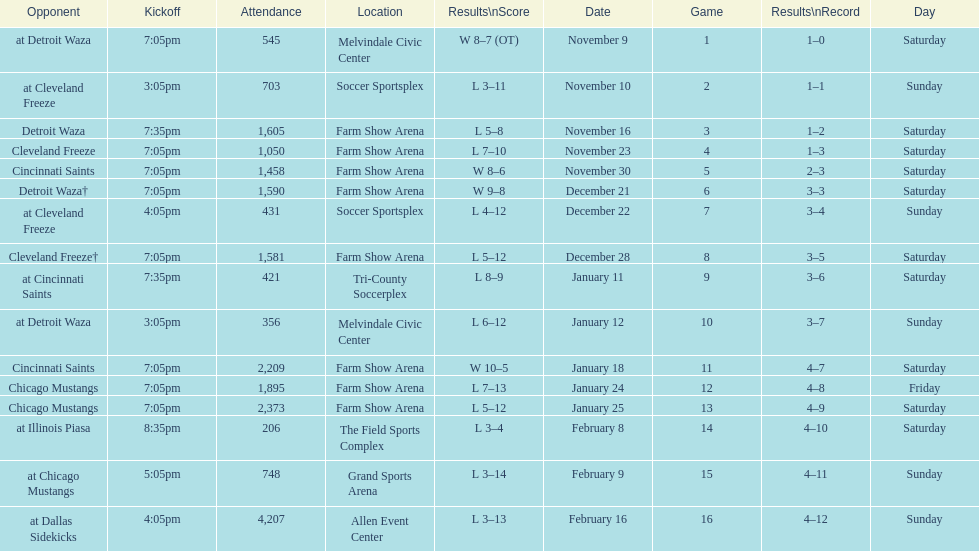Which opponent is listed after cleveland freeze in the table? Detroit Waza. Can you give me this table as a dict? {'header': ['Opponent', 'Kickoff', 'Attendance', 'Location', 'Results\\nScore', 'Date', 'Game', 'Results\\nRecord', 'Day'], 'rows': [['at Detroit Waza', '7:05pm', '545', 'Melvindale Civic Center', 'W 8–7 (OT)', 'November 9', '1', '1–0', 'Saturday'], ['at Cleveland Freeze', '3:05pm', '703', 'Soccer Sportsplex', 'L 3–11', 'November 10', '2', '1–1', 'Sunday'], ['Detroit Waza', '7:35pm', '1,605', 'Farm Show Arena', 'L 5–8', 'November 16', '3', '1–2', 'Saturday'], ['Cleveland Freeze', '7:05pm', '1,050', 'Farm Show Arena', 'L 7–10', 'November 23', '4', '1–3', 'Saturday'], ['Cincinnati Saints', '7:05pm', '1,458', 'Farm Show Arena', 'W 8–6', 'November 30', '5', '2–3', 'Saturday'], ['Detroit Waza†', '7:05pm', '1,590', 'Farm Show Arena', 'W 9–8', 'December 21', '6', '3–3', 'Saturday'], ['at Cleveland Freeze', '4:05pm', '431', 'Soccer Sportsplex', 'L 4–12', 'December 22', '7', '3–4', 'Sunday'], ['Cleveland Freeze†', '7:05pm', '1,581', 'Farm Show Arena', 'L 5–12', 'December 28', '8', '3–5', 'Saturday'], ['at Cincinnati Saints', '7:35pm', '421', 'Tri-County Soccerplex', 'L 8–9', 'January 11', '9', '3–6', 'Saturday'], ['at Detroit Waza', '3:05pm', '356', 'Melvindale Civic Center', 'L 6–12', 'January 12', '10', '3–7', 'Sunday'], ['Cincinnati Saints', '7:05pm', '2,209', 'Farm Show Arena', 'W 10–5', 'January 18', '11', '4–7', 'Saturday'], ['Chicago Mustangs', '7:05pm', '1,895', 'Farm Show Arena', 'L 7–13', 'January 24', '12', '4–8', 'Friday'], ['Chicago Mustangs', '7:05pm', '2,373', 'Farm Show Arena', 'L 5–12', 'January 25', '13', '4–9', 'Saturday'], ['at Illinois Piasa', '8:35pm', '206', 'The Field Sports Complex', 'L 3–4', 'February 8', '14', '4–10', 'Saturday'], ['at Chicago Mustangs', '5:05pm', '748', 'Grand Sports Arena', 'L 3–14', 'February 9', '15', '4–11', 'Sunday'], ['at Dallas Sidekicks', '4:05pm', '4,207', 'Allen Event Center', 'L 3–13', 'February 16', '16', '4–12', 'Sunday']]} 